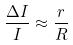Convert formula to latex. <formula><loc_0><loc_0><loc_500><loc_500>\frac { \Delta I } { I } \approx \frac { r } { R }</formula> 